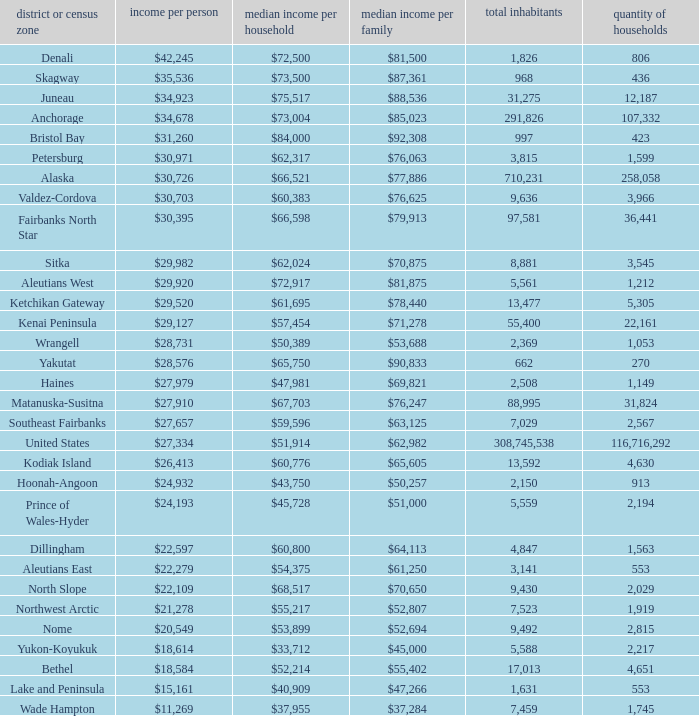Which borough or census area has a $59,596 median household income? Southeast Fairbanks. 